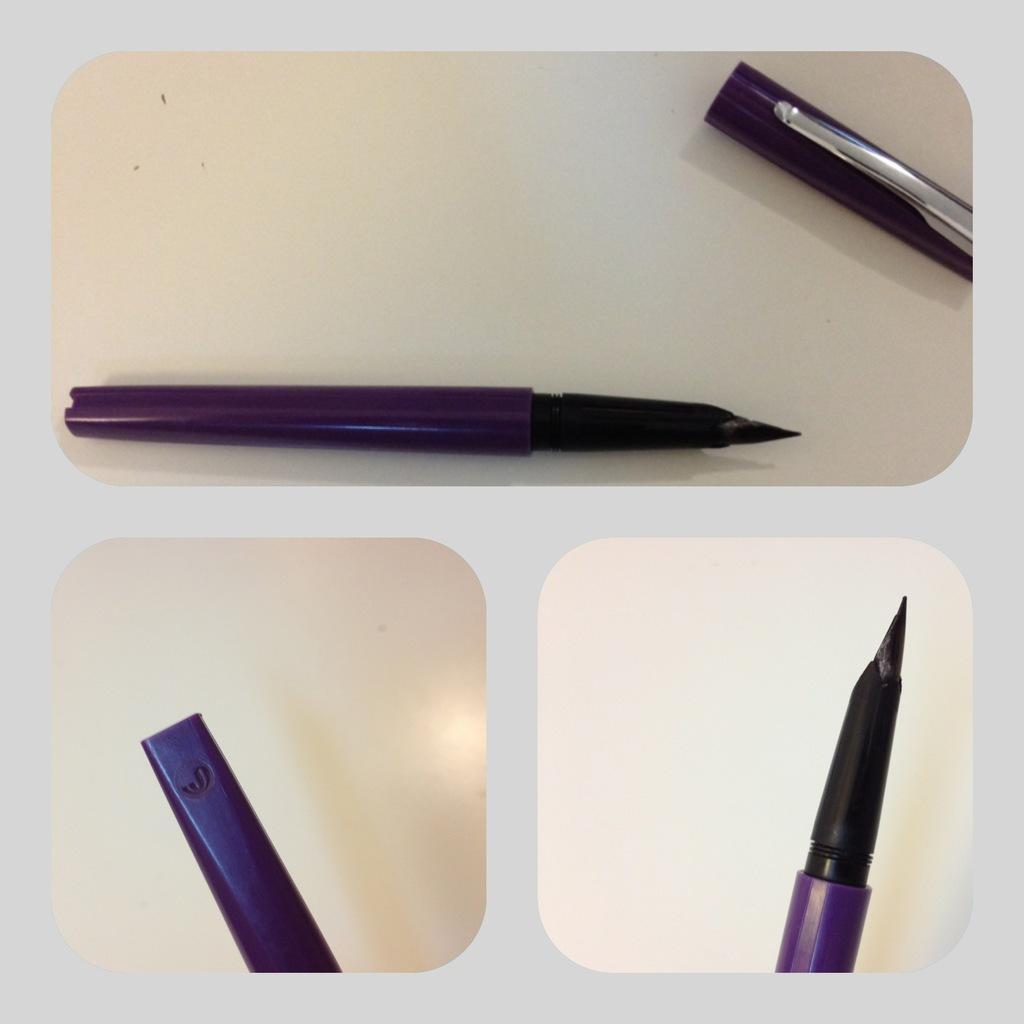Please provide a concise description of this image. This is a collage image. In this image I can see the pen and the pen cap which are in purple and silver color. These are on the cream color surface. 